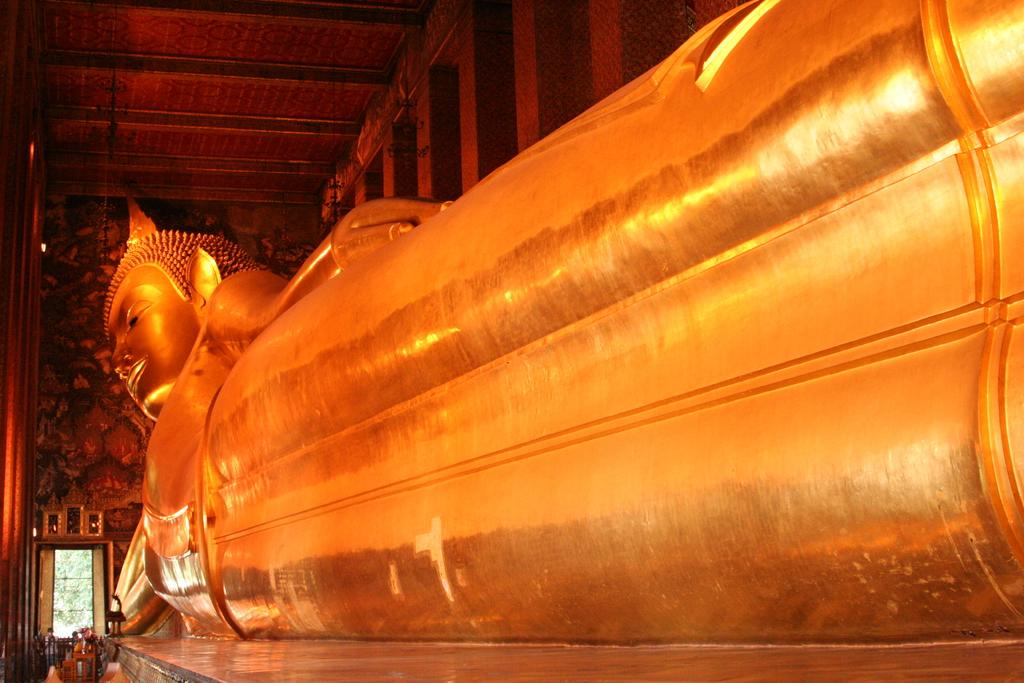What is the main subject in the center of the image? There is a statue in the center of the image. What can be seen at the bottom of the image? There are persons at the bottom of the image. What architectural features are visible in the background of the image? There is a door and a wall in the background of the image. What type of nut is being used to force open the door in the image? There is no nut or door being forced open in the image; it features a statue with persons at the bottom and a door and wall in the background. 